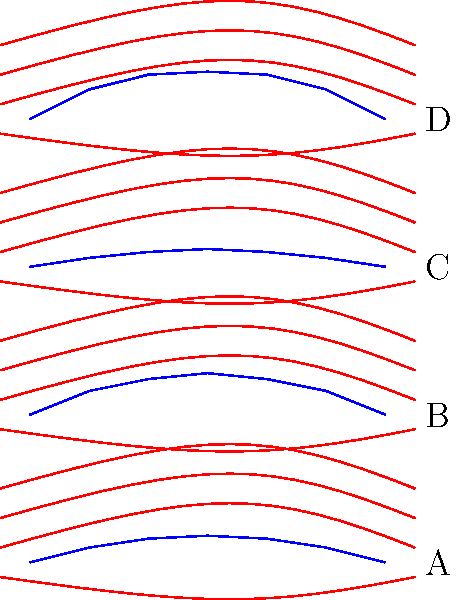As an aerospace engineer, analyze the airflow diagrams for four wing designs (A, B, C, and D) shown above. Which design would likely provide the most efficient lift-to-drag ratio for subsonic flight? To determine the most efficient wing design for subsonic flight, we need to consider the lift-to-drag ratio, which is crucial for aerodynamic efficiency. Let's analyze each design:

1. Wing A: This design has a relatively flat profile with minimal curvature. The airflow lines are slightly deflected, indicating some lift generation, but the minimal curvature suggests lower lift production.

2. Wing B: This design shows a moderate curvature with a thicker profile. The airflow lines are more significantly deflected, indicating higher lift production. The gradual curvature on both top and bottom surfaces suggests good airflow attachment, which is beneficial for reducing drag.

3. Wing C: This wing has the least curvature and thickness. The airflow lines are minimally deflected, suggesting the lowest lift production among the four designs. While it may have low drag, the lift generation is likely insufficient for efficient flight.

4. Wing D: This design has the highest curvature and thickness. While it would generate the most lift due to the significant airflow deflection, it would also likely produce the most drag due to its pronounced shape.

For subsonic flight, the most efficient lift-to-drag ratio is typically achieved with a design that balances lift generation and drag reduction. Wing B provides this balance:

1. It has sufficient curvature to generate good lift.
2. The smooth, gradual curvature helps maintain attached airflow, reducing drag.
3. It's not as extreme as Wing D, which would likely produce excessive drag.
4. It offers better lift generation than the flatter profiles of Wings A and C.

Therefore, Wing B would likely provide the most efficient lift-to-drag ratio for subsonic flight.
Answer: Wing B 